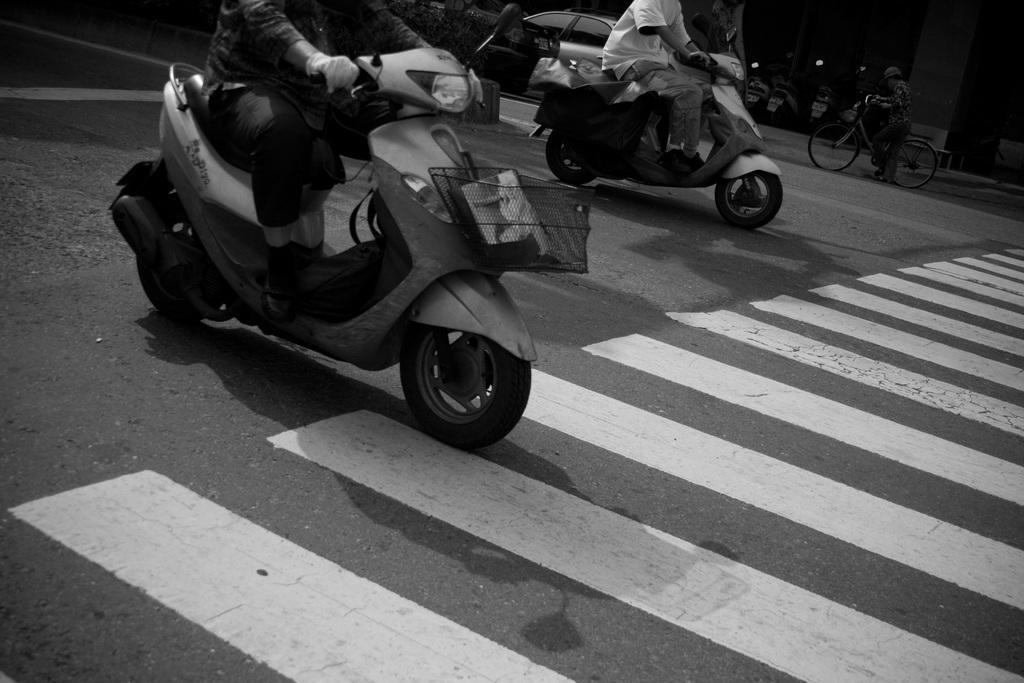How would you summarize this image in a sentence or two? These two persons riding bike. This person holding bicycle. This is road. This is car. 